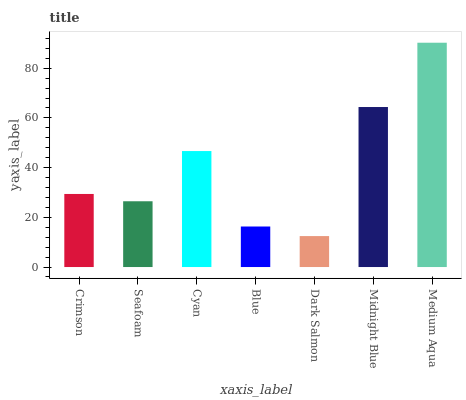Is Dark Salmon the minimum?
Answer yes or no. Yes. Is Medium Aqua the maximum?
Answer yes or no. Yes. Is Seafoam the minimum?
Answer yes or no. No. Is Seafoam the maximum?
Answer yes or no. No. Is Crimson greater than Seafoam?
Answer yes or no. Yes. Is Seafoam less than Crimson?
Answer yes or no. Yes. Is Seafoam greater than Crimson?
Answer yes or no. No. Is Crimson less than Seafoam?
Answer yes or no. No. Is Crimson the high median?
Answer yes or no. Yes. Is Crimson the low median?
Answer yes or no. Yes. Is Seafoam the high median?
Answer yes or no. No. Is Blue the low median?
Answer yes or no. No. 